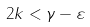<formula> <loc_0><loc_0><loc_500><loc_500>2 k < \gamma - \varepsilon</formula> 